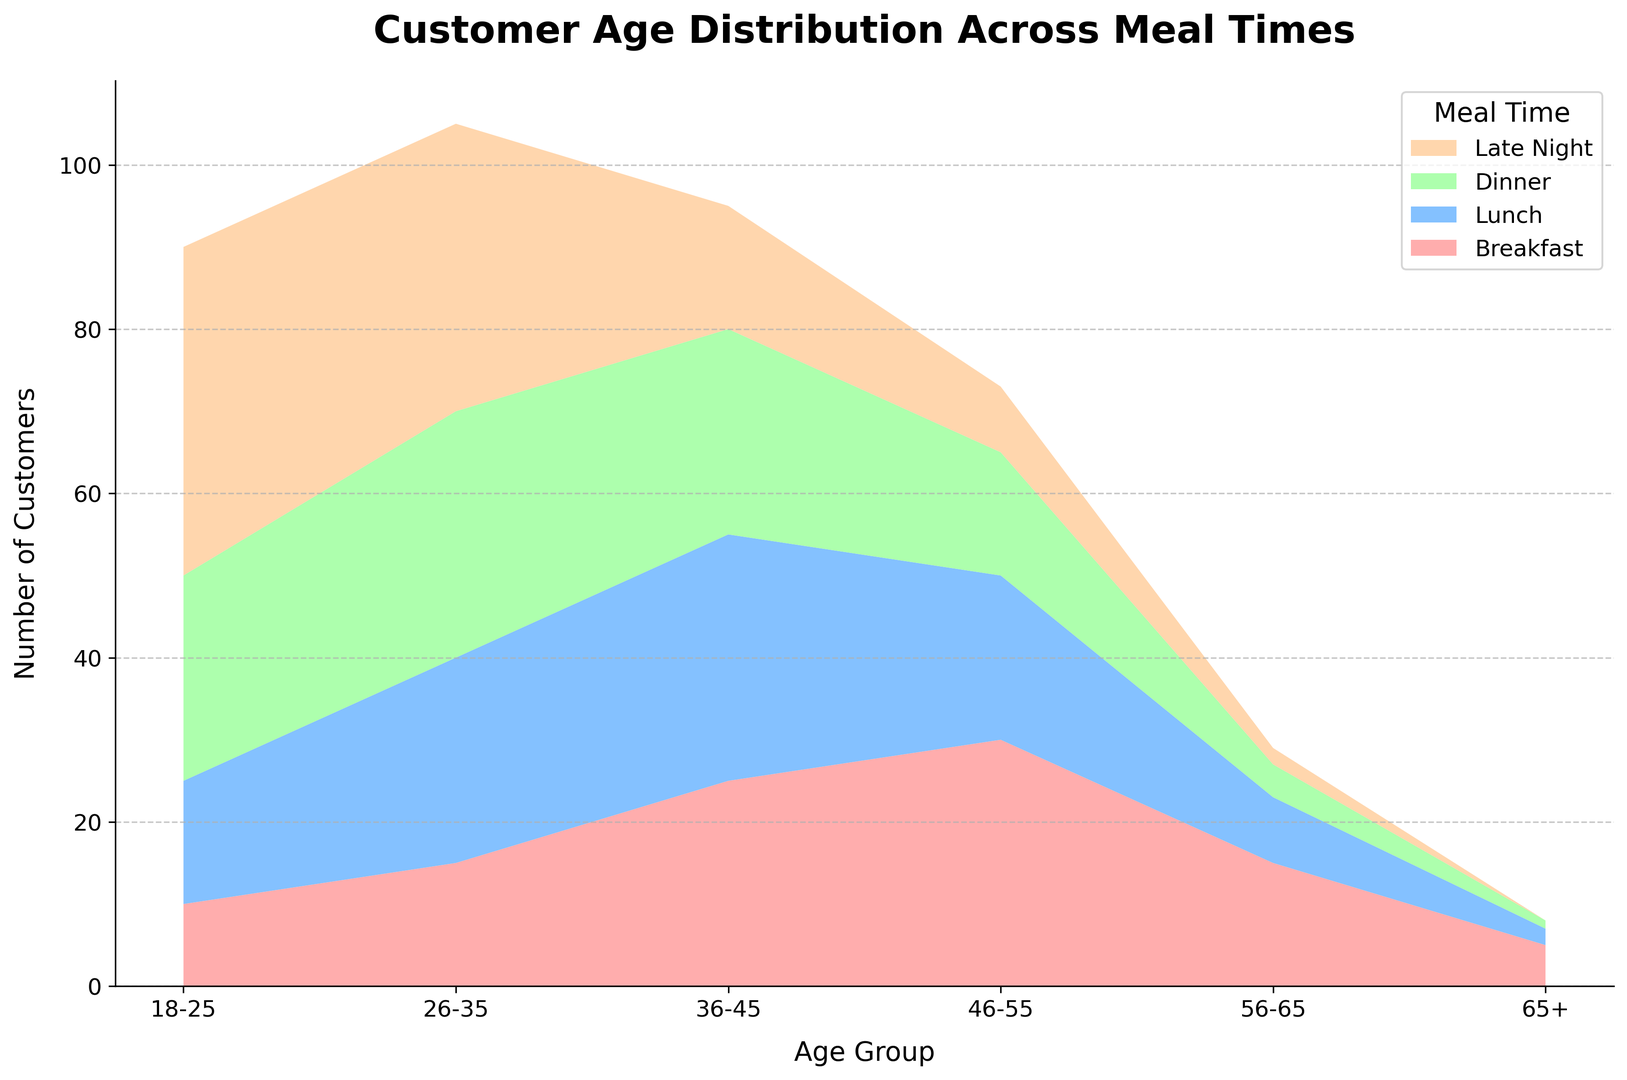What meal time has the highest number of customers in the 18-25 age group? By looking at the chart, we can see the highest point for the 18-25 age group under the "Late Night" section.
Answer: Late Night How does the customer distribution in the 26-35 age group for Dinner compare to Lunch? By comparing the heights of the Dinner and Lunch areas for the 26-35 age group, the Dinner area is slightly higher than Lunch.
Answer: Dinner has more customers What age group has the most significant drop in the number of customers between Dinner and Late Night? By observing the chart, the 36-45 age group shows the most significant decrease between Dinner and Late Night areas.
Answer: 36-45 Which age group has the lowest customer count for Breakfast? The age group with the smallest height in the Breakfast section is 65+.
Answer: 65+ Compare the number of customers for the 46-55 group at Breakfast and Late Night. How many more customers are there at Breakfast? The graph shows the 46-55 group has 30 customers at Breakfast and 8 at Late Night. So, 30 - 8 = 22 more customers.
Answer: 22 What is the sum of customers in the 56-65 age group across all meal times? Adding all values for the 56-65 age group: 15 (Breakfast) + 8 (Lunch) + 4 (Dinner) + 2 (Late Night) = 29.
Answer: 29 What is the difference in the number of customers between the 26-35 age group at Dinner and the 56-65 age group at Late Night? The 26-35 age group at Dinner has 30, while the 56-65 group at Late Night has 2. So, 30 - 2 = 28.
Answer: 28 Which meal time has the lowest customer count for the 65+ age group and how many? Checking the graph, the 65+ age group has the lowest count during Late Night, with 0 customers.
Answer: Late Night, 0 